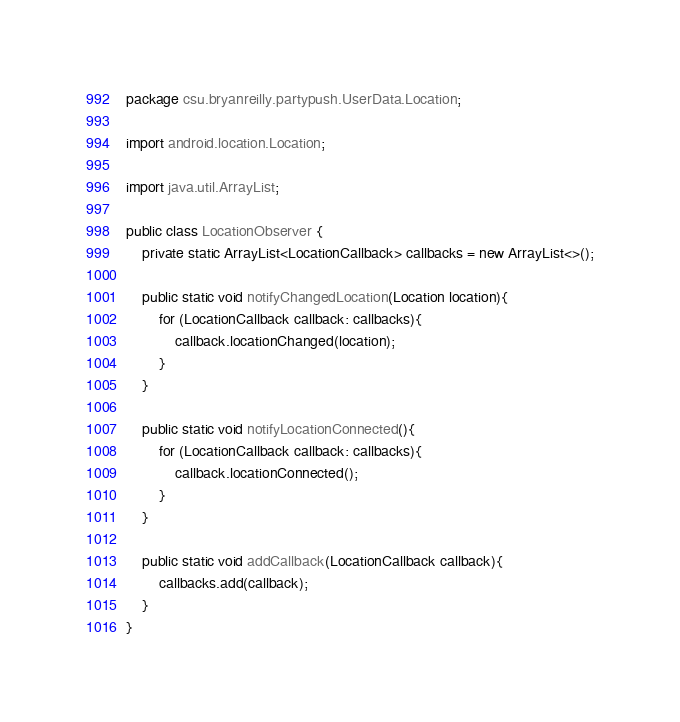Convert code to text. <code><loc_0><loc_0><loc_500><loc_500><_Java_>package csu.bryanreilly.partypush.UserData.Location;

import android.location.Location;

import java.util.ArrayList;

public class LocationObserver {
    private static ArrayList<LocationCallback> callbacks = new ArrayList<>();

    public static void notifyChangedLocation(Location location){
        for (LocationCallback callback: callbacks){
            callback.locationChanged(location);
        }
    }

    public static void notifyLocationConnected(){
        for (LocationCallback callback: callbacks){
            callback.locationConnected();
        }
    }

    public static void addCallback(LocationCallback callback){
        callbacks.add(callback);
    }
}
</code> 